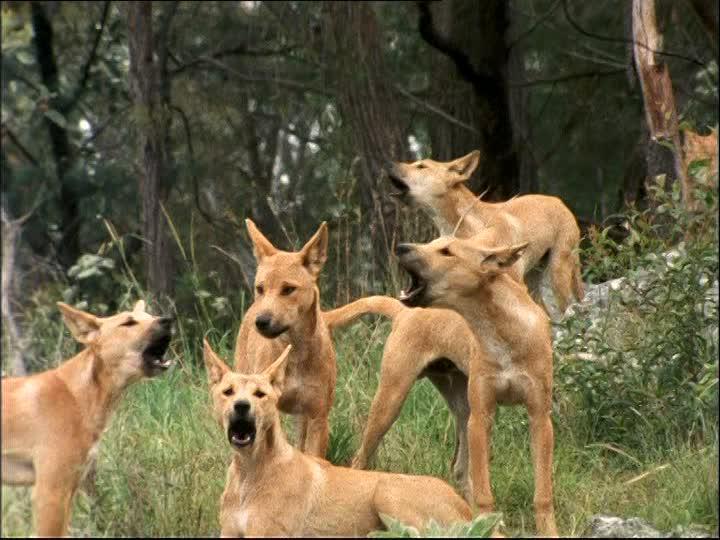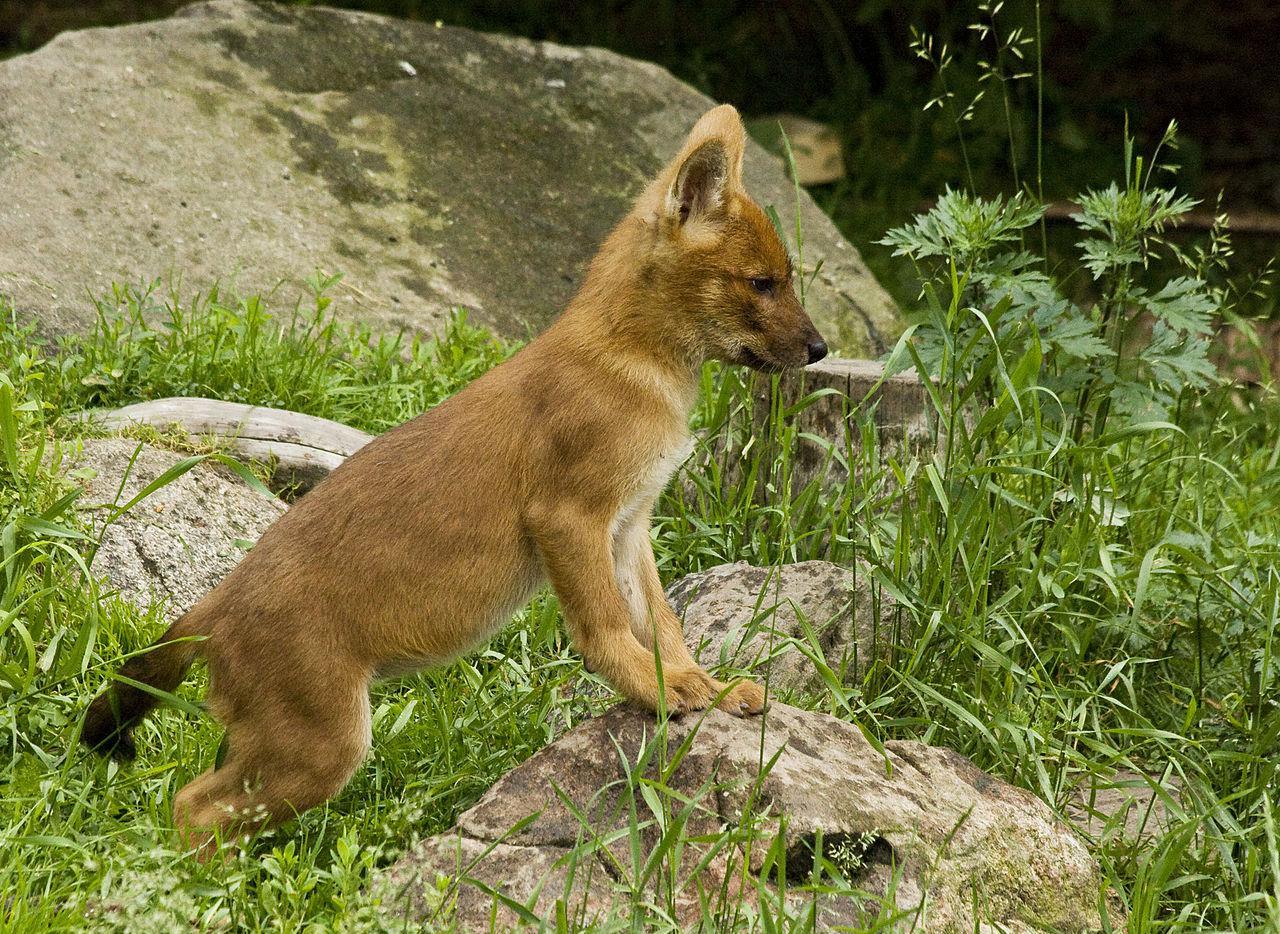The first image is the image on the left, the second image is the image on the right. Analyze the images presented: Is the assertion "There are more animals in the left image than there are in the right image." valid? Answer yes or no. Yes. The first image is the image on the left, the second image is the image on the right. For the images shown, is this caption "There's no more than one wild dog in the right image." true? Answer yes or no. Yes. 